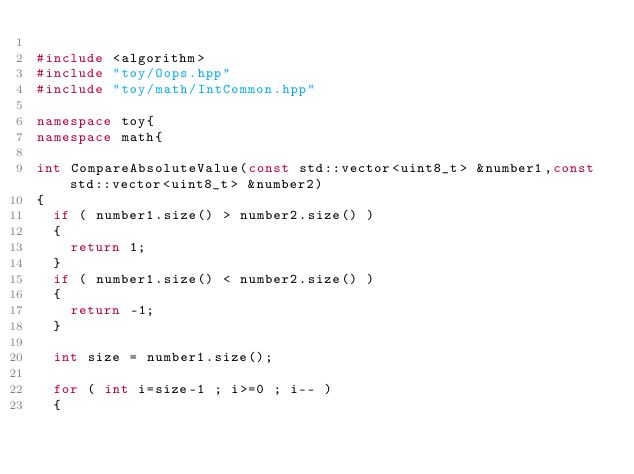<code> <loc_0><loc_0><loc_500><loc_500><_C++_>
#include <algorithm>
#include "toy/Oops.hpp"
#include "toy/math/IntCommon.hpp"

namespace toy{
namespace math{

int CompareAbsoluteValue(const std::vector<uint8_t> &number1,const std::vector<uint8_t> &number2)
{
	if ( number1.size() > number2.size() )
	{
		return 1;
	}
	if ( number1.size() < number2.size() )
	{
		return -1;
	}

	int size = number1.size();

	for ( int i=size-1 ; i>=0 ; i-- )
	{</code> 